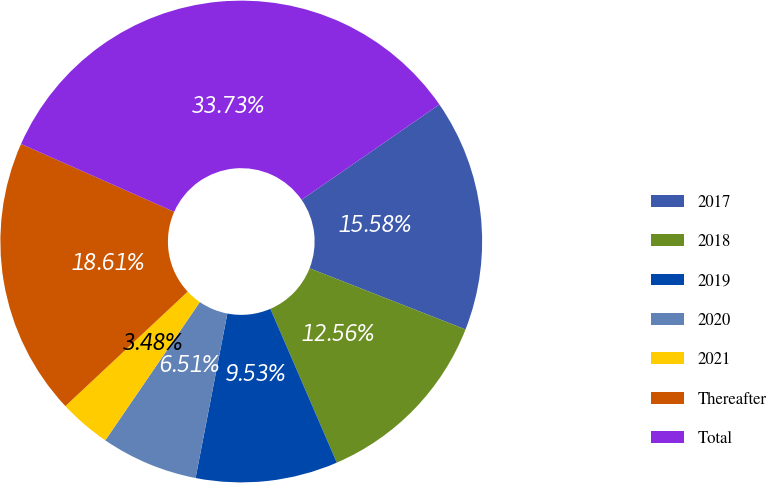<chart> <loc_0><loc_0><loc_500><loc_500><pie_chart><fcel>2017<fcel>2018<fcel>2019<fcel>2020<fcel>2021<fcel>Thereafter<fcel>Total<nl><fcel>15.58%<fcel>12.56%<fcel>9.53%<fcel>6.51%<fcel>3.48%<fcel>18.61%<fcel>33.73%<nl></chart> 